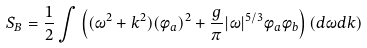Convert formula to latex. <formula><loc_0><loc_0><loc_500><loc_500>S _ { B } = \frac { 1 } { 2 } \int \left ( ( \omega ^ { 2 } + k ^ { 2 } ) ( \phi _ { a } ) ^ { 2 } + \frac { g } { \pi } | \omega | ^ { 5 / 3 } \phi _ { a } \phi _ { b } \right ) ( d \omega d k )</formula> 